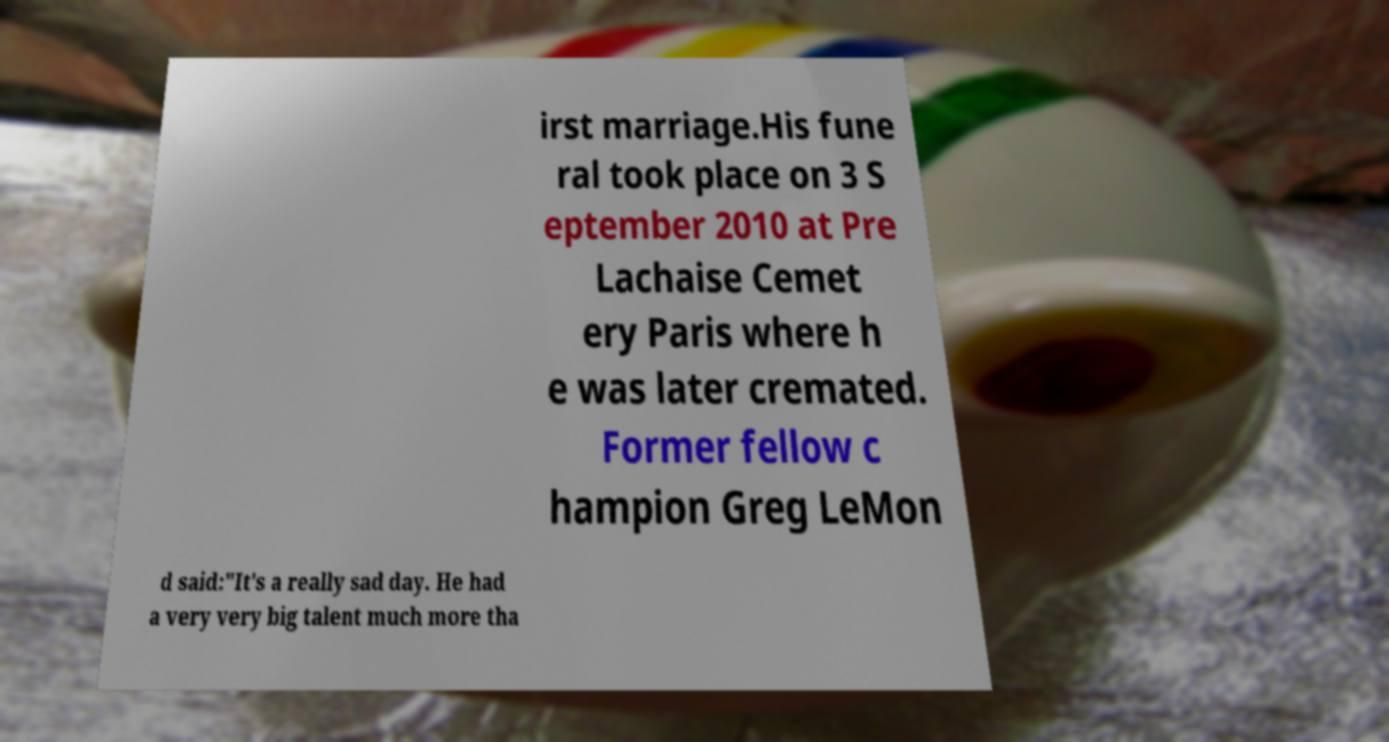Can you read and provide the text displayed in the image?This photo seems to have some interesting text. Can you extract and type it out for me? irst marriage.His fune ral took place on 3 S eptember 2010 at Pre Lachaise Cemet ery Paris where h e was later cremated. Former fellow c hampion Greg LeMon d said:"It's a really sad day. He had a very very big talent much more tha 